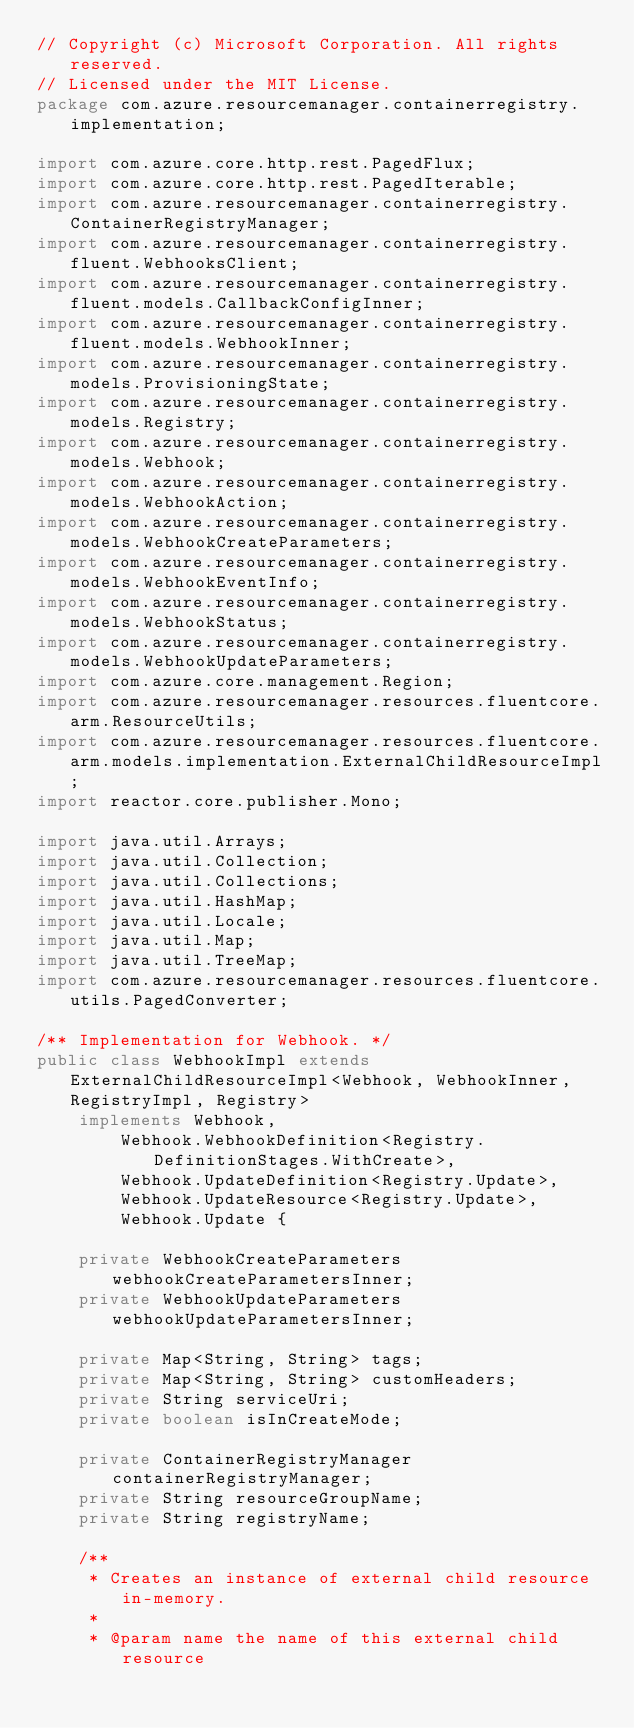Convert code to text. <code><loc_0><loc_0><loc_500><loc_500><_Java_>// Copyright (c) Microsoft Corporation. All rights reserved.
// Licensed under the MIT License.
package com.azure.resourcemanager.containerregistry.implementation;

import com.azure.core.http.rest.PagedFlux;
import com.azure.core.http.rest.PagedIterable;
import com.azure.resourcemanager.containerregistry.ContainerRegistryManager;
import com.azure.resourcemanager.containerregistry.fluent.WebhooksClient;
import com.azure.resourcemanager.containerregistry.fluent.models.CallbackConfigInner;
import com.azure.resourcemanager.containerregistry.fluent.models.WebhookInner;
import com.azure.resourcemanager.containerregistry.models.ProvisioningState;
import com.azure.resourcemanager.containerregistry.models.Registry;
import com.azure.resourcemanager.containerregistry.models.Webhook;
import com.azure.resourcemanager.containerregistry.models.WebhookAction;
import com.azure.resourcemanager.containerregistry.models.WebhookCreateParameters;
import com.azure.resourcemanager.containerregistry.models.WebhookEventInfo;
import com.azure.resourcemanager.containerregistry.models.WebhookStatus;
import com.azure.resourcemanager.containerregistry.models.WebhookUpdateParameters;
import com.azure.core.management.Region;
import com.azure.resourcemanager.resources.fluentcore.arm.ResourceUtils;
import com.azure.resourcemanager.resources.fluentcore.arm.models.implementation.ExternalChildResourceImpl;
import reactor.core.publisher.Mono;

import java.util.Arrays;
import java.util.Collection;
import java.util.Collections;
import java.util.HashMap;
import java.util.Locale;
import java.util.Map;
import java.util.TreeMap;
import com.azure.resourcemanager.resources.fluentcore.utils.PagedConverter;

/** Implementation for Webhook. */
public class WebhookImpl extends ExternalChildResourceImpl<Webhook, WebhookInner, RegistryImpl, Registry>
    implements Webhook,
        Webhook.WebhookDefinition<Registry.DefinitionStages.WithCreate>,
        Webhook.UpdateDefinition<Registry.Update>,
        Webhook.UpdateResource<Registry.Update>,
        Webhook.Update {

    private WebhookCreateParameters webhookCreateParametersInner;
    private WebhookUpdateParameters webhookUpdateParametersInner;

    private Map<String, String> tags;
    private Map<String, String> customHeaders;
    private String serviceUri;
    private boolean isInCreateMode;

    private ContainerRegistryManager containerRegistryManager;
    private String resourceGroupName;
    private String registryName;

    /**
     * Creates an instance of external child resource in-memory.
     *
     * @param name the name of this external child resource</code> 